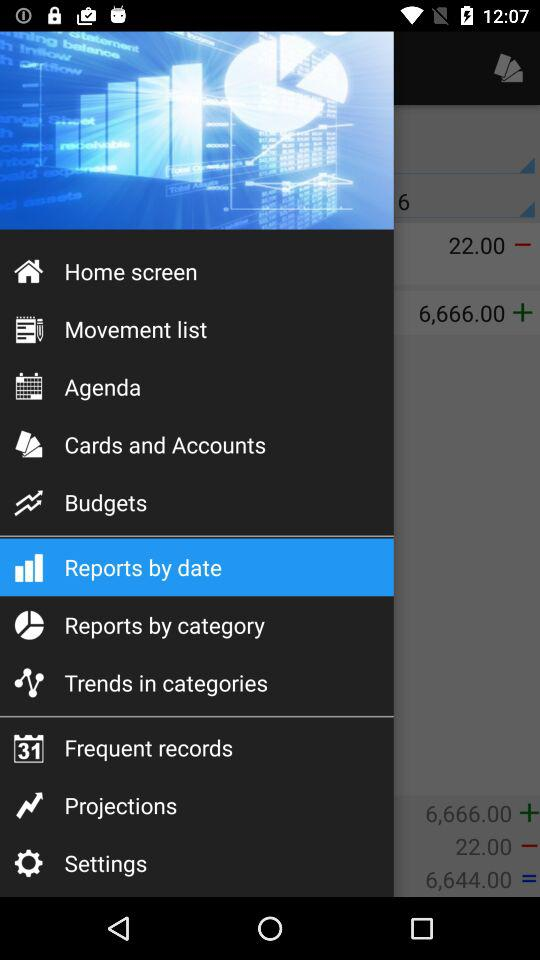Which item has been selected? The item that has been selected is "Reports by date". 